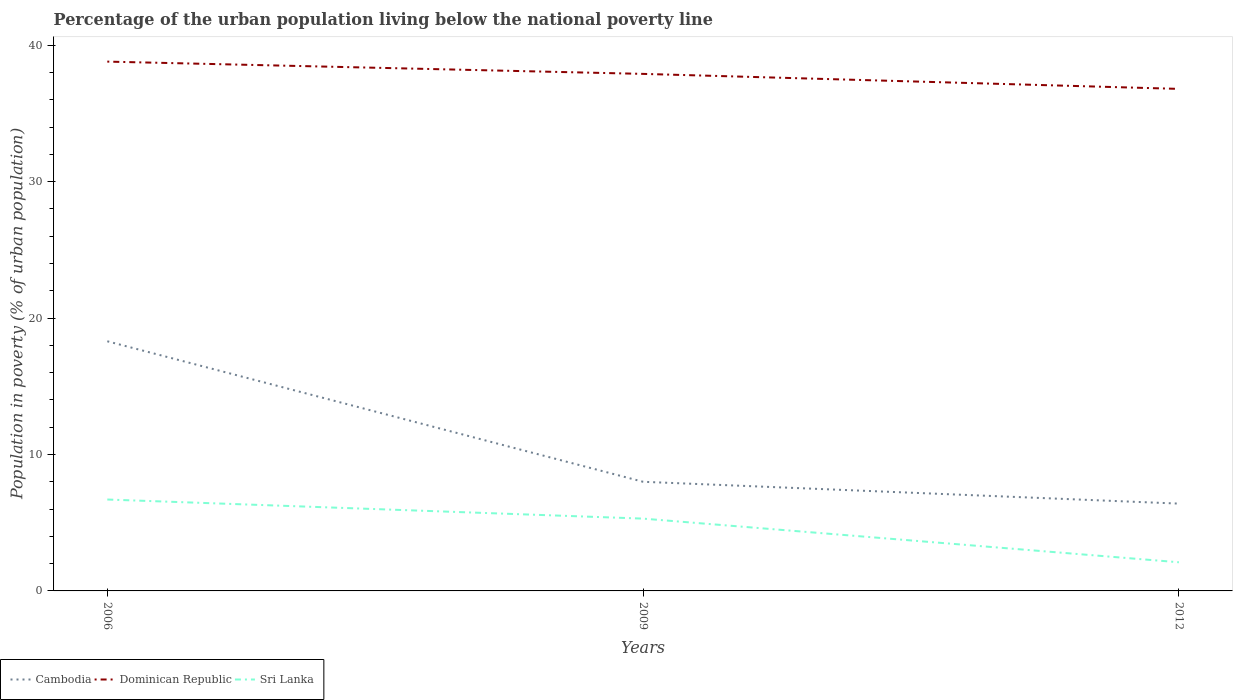Is the number of lines equal to the number of legend labels?
Your answer should be very brief. Yes. What is the total percentage of the urban population living below the national poverty line in Dominican Republic in the graph?
Give a very brief answer. 0.9. Is the percentage of the urban population living below the national poverty line in Cambodia strictly greater than the percentage of the urban population living below the national poverty line in Dominican Republic over the years?
Offer a terse response. Yes. How many lines are there?
Offer a very short reply. 3. How many years are there in the graph?
Offer a terse response. 3. Does the graph contain any zero values?
Make the answer very short. No. Does the graph contain grids?
Ensure brevity in your answer.  No. What is the title of the graph?
Offer a very short reply. Percentage of the urban population living below the national poverty line. What is the label or title of the Y-axis?
Provide a short and direct response. Population in poverty (% of urban population). What is the Population in poverty (% of urban population) of Dominican Republic in 2006?
Provide a succinct answer. 38.8. What is the Population in poverty (% of urban population) in Cambodia in 2009?
Ensure brevity in your answer.  8. What is the Population in poverty (% of urban population) of Dominican Republic in 2009?
Make the answer very short. 37.9. What is the Population in poverty (% of urban population) of Sri Lanka in 2009?
Offer a terse response. 5.3. What is the Population in poverty (% of urban population) of Dominican Republic in 2012?
Offer a terse response. 36.8. Across all years, what is the maximum Population in poverty (% of urban population) in Cambodia?
Offer a terse response. 18.3. Across all years, what is the maximum Population in poverty (% of urban population) of Dominican Republic?
Your answer should be very brief. 38.8. Across all years, what is the minimum Population in poverty (% of urban population) in Dominican Republic?
Provide a succinct answer. 36.8. Across all years, what is the minimum Population in poverty (% of urban population) in Sri Lanka?
Provide a succinct answer. 2.1. What is the total Population in poverty (% of urban population) in Cambodia in the graph?
Provide a succinct answer. 32.7. What is the total Population in poverty (% of urban population) in Dominican Republic in the graph?
Offer a very short reply. 113.5. What is the total Population in poverty (% of urban population) in Sri Lanka in the graph?
Ensure brevity in your answer.  14.1. What is the difference between the Population in poverty (% of urban population) of Cambodia in 2006 and that in 2009?
Ensure brevity in your answer.  10.3. What is the difference between the Population in poverty (% of urban population) in Cambodia in 2006 and that in 2012?
Ensure brevity in your answer.  11.9. What is the difference between the Population in poverty (% of urban population) in Dominican Republic in 2006 and that in 2012?
Provide a succinct answer. 2. What is the difference between the Population in poverty (% of urban population) in Cambodia in 2009 and that in 2012?
Your answer should be very brief. 1.6. What is the difference between the Population in poverty (% of urban population) in Dominican Republic in 2009 and that in 2012?
Provide a short and direct response. 1.1. What is the difference between the Population in poverty (% of urban population) of Cambodia in 2006 and the Population in poverty (% of urban population) of Dominican Republic in 2009?
Provide a short and direct response. -19.6. What is the difference between the Population in poverty (% of urban population) of Dominican Republic in 2006 and the Population in poverty (% of urban population) of Sri Lanka in 2009?
Give a very brief answer. 33.5. What is the difference between the Population in poverty (% of urban population) in Cambodia in 2006 and the Population in poverty (% of urban population) in Dominican Republic in 2012?
Give a very brief answer. -18.5. What is the difference between the Population in poverty (% of urban population) of Dominican Republic in 2006 and the Population in poverty (% of urban population) of Sri Lanka in 2012?
Ensure brevity in your answer.  36.7. What is the difference between the Population in poverty (% of urban population) of Cambodia in 2009 and the Population in poverty (% of urban population) of Dominican Republic in 2012?
Offer a terse response. -28.8. What is the difference between the Population in poverty (% of urban population) in Dominican Republic in 2009 and the Population in poverty (% of urban population) in Sri Lanka in 2012?
Keep it short and to the point. 35.8. What is the average Population in poverty (% of urban population) of Dominican Republic per year?
Offer a terse response. 37.83. What is the average Population in poverty (% of urban population) of Sri Lanka per year?
Make the answer very short. 4.7. In the year 2006, what is the difference between the Population in poverty (% of urban population) in Cambodia and Population in poverty (% of urban population) in Dominican Republic?
Ensure brevity in your answer.  -20.5. In the year 2006, what is the difference between the Population in poverty (% of urban population) of Dominican Republic and Population in poverty (% of urban population) of Sri Lanka?
Offer a terse response. 32.1. In the year 2009, what is the difference between the Population in poverty (% of urban population) of Cambodia and Population in poverty (% of urban population) of Dominican Republic?
Your response must be concise. -29.9. In the year 2009, what is the difference between the Population in poverty (% of urban population) in Dominican Republic and Population in poverty (% of urban population) in Sri Lanka?
Ensure brevity in your answer.  32.6. In the year 2012, what is the difference between the Population in poverty (% of urban population) in Cambodia and Population in poverty (% of urban population) in Dominican Republic?
Your answer should be very brief. -30.4. In the year 2012, what is the difference between the Population in poverty (% of urban population) in Cambodia and Population in poverty (% of urban population) in Sri Lanka?
Give a very brief answer. 4.3. In the year 2012, what is the difference between the Population in poverty (% of urban population) of Dominican Republic and Population in poverty (% of urban population) of Sri Lanka?
Give a very brief answer. 34.7. What is the ratio of the Population in poverty (% of urban population) in Cambodia in 2006 to that in 2009?
Your response must be concise. 2.29. What is the ratio of the Population in poverty (% of urban population) in Dominican Republic in 2006 to that in 2009?
Offer a terse response. 1.02. What is the ratio of the Population in poverty (% of urban population) of Sri Lanka in 2006 to that in 2009?
Provide a succinct answer. 1.26. What is the ratio of the Population in poverty (% of urban population) in Cambodia in 2006 to that in 2012?
Provide a succinct answer. 2.86. What is the ratio of the Population in poverty (% of urban population) in Dominican Republic in 2006 to that in 2012?
Your answer should be very brief. 1.05. What is the ratio of the Population in poverty (% of urban population) in Sri Lanka in 2006 to that in 2012?
Ensure brevity in your answer.  3.19. What is the ratio of the Population in poverty (% of urban population) of Dominican Republic in 2009 to that in 2012?
Make the answer very short. 1.03. What is the ratio of the Population in poverty (% of urban population) in Sri Lanka in 2009 to that in 2012?
Ensure brevity in your answer.  2.52. What is the difference between the highest and the second highest Population in poverty (% of urban population) in Dominican Republic?
Offer a terse response. 0.9. What is the difference between the highest and the lowest Population in poverty (% of urban population) of Dominican Republic?
Your response must be concise. 2. 